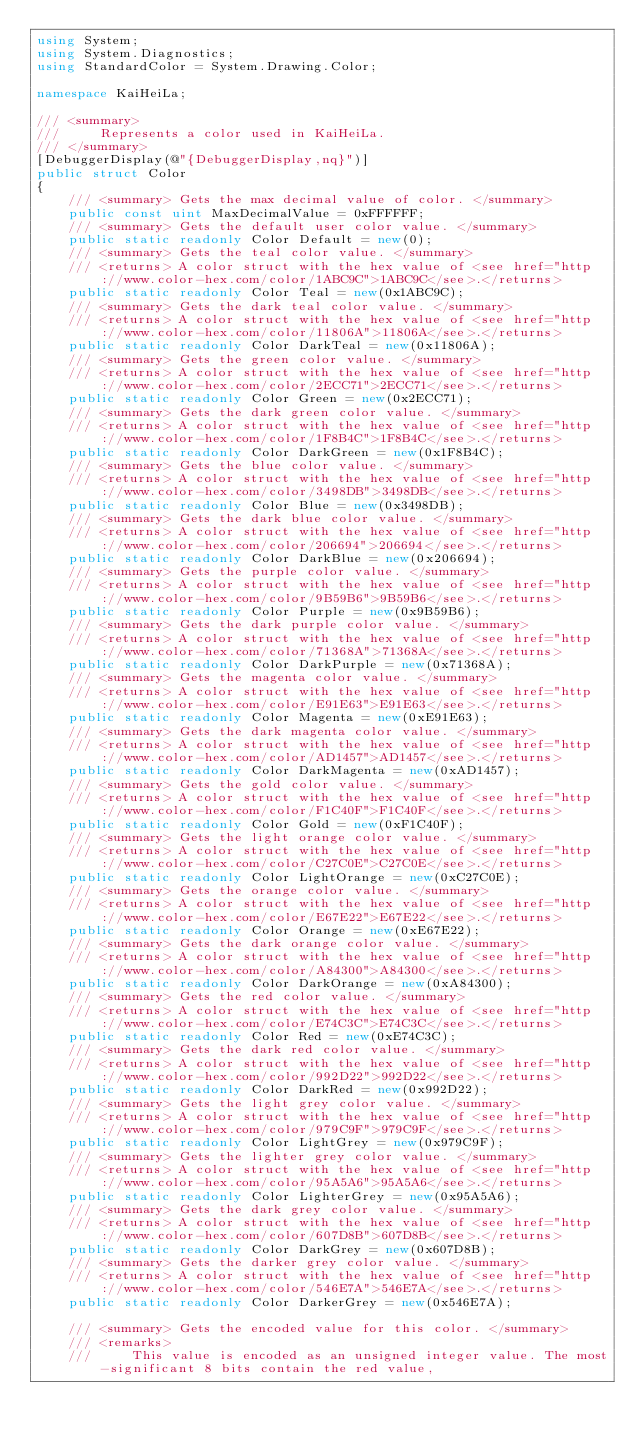<code> <loc_0><loc_0><loc_500><loc_500><_C#_>using System;
using System.Diagnostics;
using StandardColor = System.Drawing.Color;

namespace KaiHeiLa;

/// <summary>
///     Represents a color used in KaiHeiLa.
/// </summary>
[DebuggerDisplay(@"{DebuggerDisplay,nq}")]
public struct Color
{
    /// <summary> Gets the max decimal value of color. </summary>
    public const uint MaxDecimalValue = 0xFFFFFF;
    /// <summary> Gets the default user color value. </summary>
    public static readonly Color Default = new(0);
    /// <summary> Gets the teal color value. </summary>
    /// <returns> A color struct with the hex value of <see href="http://www.color-hex.com/color/1ABC9C">1ABC9C</see>.</returns>
    public static readonly Color Teal = new(0x1ABC9C);
    /// <summary> Gets the dark teal color value. </summary>
    /// <returns> A color struct with the hex value of <see href="http://www.color-hex.com/color/11806A">11806A</see>.</returns>
    public static readonly Color DarkTeal = new(0x11806A);
    /// <summary> Gets the green color value. </summary>
    /// <returns> A color struct with the hex value of <see href="http://www.color-hex.com/color/2ECC71">2ECC71</see>.</returns>
    public static readonly Color Green = new(0x2ECC71);
    /// <summary> Gets the dark green color value. </summary>
    /// <returns> A color struct with the hex value of <see href="http://www.color-hex.com/color/1F8B4C">1F8B4C</see>.</returns>
    public static readonly Color DarkGreen = new(0x1F8B4C);
    /// <summary> Gets the blue color value. </summary>
    /// <returns> A color struct with the hex value of <see href="http://www.color-hex.com/color/3498DB">3498DB</see>.</returns>
    public static readonly Color Blue = new(0x3498DB);
    /// <summary> Gets the dark blue color value. </summary>
    /// <returns> A color struct with the hex value of <see href="http://www.color-hex.com/color/206694">206694</see>.</returns>
    public static readonly Color DarkBlue = new(0x206694);
    /// <summary> Gets the purple color value. </summary>
    /// <returns> A color struct with the hex value of <see href="http://www.color-hex.com/color/9B59B6">9B59B6</see>.</returns>
    public static readonly Color Purple = new(0x9B59B6);
    /// <summary> Gets the dark purple color value. </summary>
    /// <returns> A color struct with the hex value of <see href="http://www.color-hex.com/color/71368A">71368A</see>.</returns>
    public static readonly Color DarkPurple = new(0x71368A);
    /// <summary> Gets the magenta color value. </summary>
    /// <returns> A color struct with the hex value of <see href="http://www.color-hex.com/color/E91E63">E91E63</see>.</returns>
    public static readonly Color Magenta = new(0xE91E63);
    /// <summary> Gets the dark magenta color value. </summary>
    /// <returns> A color struct with the hex value of <see href="http://www.color-hex.com/color/AD1457">AD1457</see>.</returns>
    public static readonly Color DarkMagenta = new(0xAD1457);
    /// <summary> Gets the gold color value. </summary>
    /// <returns> A color struct with the hex value of <see href="http://www.color-hex.com/color/F1C40F">F1C40F</see>.</returns>
    public static readonly Color Gold = new(0xF1C40F);
    /// <summary> Gets the light orange color value. </summary>
    /// <returns> A color struct with the hex value of <see href="http://www.color-hex.com/color/C27C0E">C27C0E</see>.</returns>
    public static readonly Color LightOrange = new(0xC27C0E);
    /// <summary> Gets the orange color value. </summary>
    /// <returns> A color struct with the hex value of <see href="http://www.color-hex.com/color/E67E22">E67E22</see>.</returns>
    public static readonly Color Orange = new(0xE67E22);
    /// <summary> Gets the dark orange color value. </summary>
    /// <returns> A color struct with the hex value of <see href="http://www.color-hex.com/color/A84300">A84300</see>.</returns>
    public static readonly Color DarkOrange = new(0xA84300);
    /// <summary> Gets the red color value. </summary>
    /// <returns> A color struct with the hex value of <see href="http://www.color-hex.com/color/E74C3C">E74C3C</see>.</returns>
    public static readonly Color Red = new(0xE74C3C);
    /// <summary> Gets the dark red color value. </summary>
    /// <returns> A color struct with the hex value of <see href="http://www.color-hex.com/color/992D22">992D22</see>.</returns>
    public static readonly Color DarkRed = new(0x992D22);
    /// <summary> Gets the light grey color value. </summary>
    /// <returns> A color struct with the hex value of <see href="http://www.color-hex.com/color/979C9F">979C9F</see>.</returns>
    public static readonly Color LightGrey = new(0x979C9F);
    /// <summary> Gets the lighter grey color value. </summary>
    /// <returns> A color struct with the hex value of <see href="http://www.color-hex.com/color/95A5A6">95A5A6</see>.</returns>
    public static readonly Color LighterGrey = new(0x95A5A6);
    /// <summary> Gets the dark grey color value. </summary>
    /// <returns> A color struct with the hex value of <see href="http://www.color-hex.com/color/607D8B">607D8B</see>.</returns>
    public static readonly Color DarkGrey = new(0x607D8B);
    /// <summary> Gets the darker grey color value. </summary>
    /// <returns> A color struct with the hex value of <see href="http://www.color-hex.com/color/546E7A">546E7A</see>.</returns>
    public static readonly Color DarkerGrey = new(0x546E7A);

    /// <summary> Gets the encoded value for this color. </summary>
    /// <remarks>
    ///     This value is encoded as an unsigned integer value. The most-significant 8 bits contain the red value,</code> 